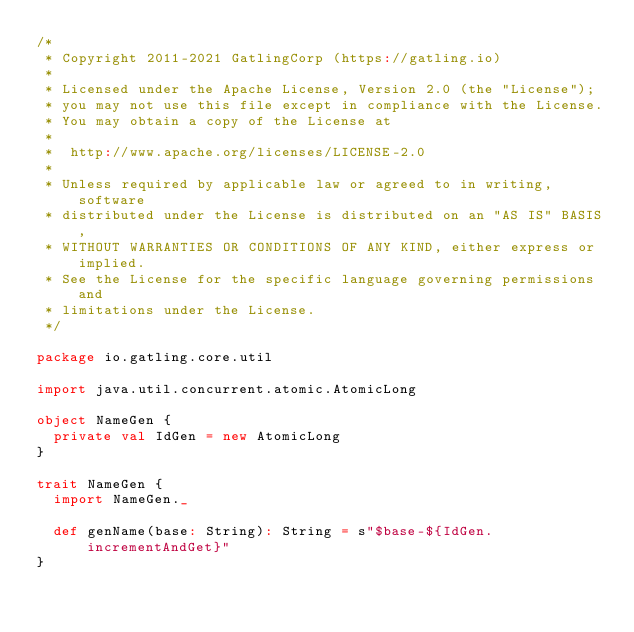<code> <loc_0><loc_0><loc_500><loc_500><_Scala_>/*
 * Copyright 2011-2021 GatlingCorp (https://gatling.io)
 *
 * Licensed under the Apache License, Version 2.0 (the "License");
 * you may not use this file except in compliance with the License.
 * You may obtain a copy of the License at
 *
 *  http://www.apache.org/licenses/LICENSE-2.0
 *
 * Unless required by applicable law or agreed to in writing, software
 * distributed under the License is distributed on an "AS IS" BASIS,
 * WITHOUT WARRANTIES OR CONDITIONS OF ANY KIND, either express or implied.
 * See the License for the specific language governing permissions and
 * limitations under the License.
 */

package io.gatling.core.util

import java.util.concurrent.atomic.AtomicLong

object NameGen {
  private val IdGen = new AtomicLong
}

trait NameGen {
  import NameGen._

  def genName(base: String): String = s"$base-${IdGen.incrementAndGet}"
}
</code> 